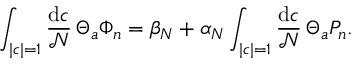Convert formula to latex. <formula><loc_0><loc_0><loc_500><loc_500>\int _ { | c | = 1 } { \frac { d c } { \mathcal { N } } } \, \Theta _ { a } \Phi _ { n } = \beta _ { N } + \alpha _ { N } \int _ { | c | = 1 } { \frac { d c } { \mathcal { N } } } \, \Theta _ { a } P _ { n } .</formula> 